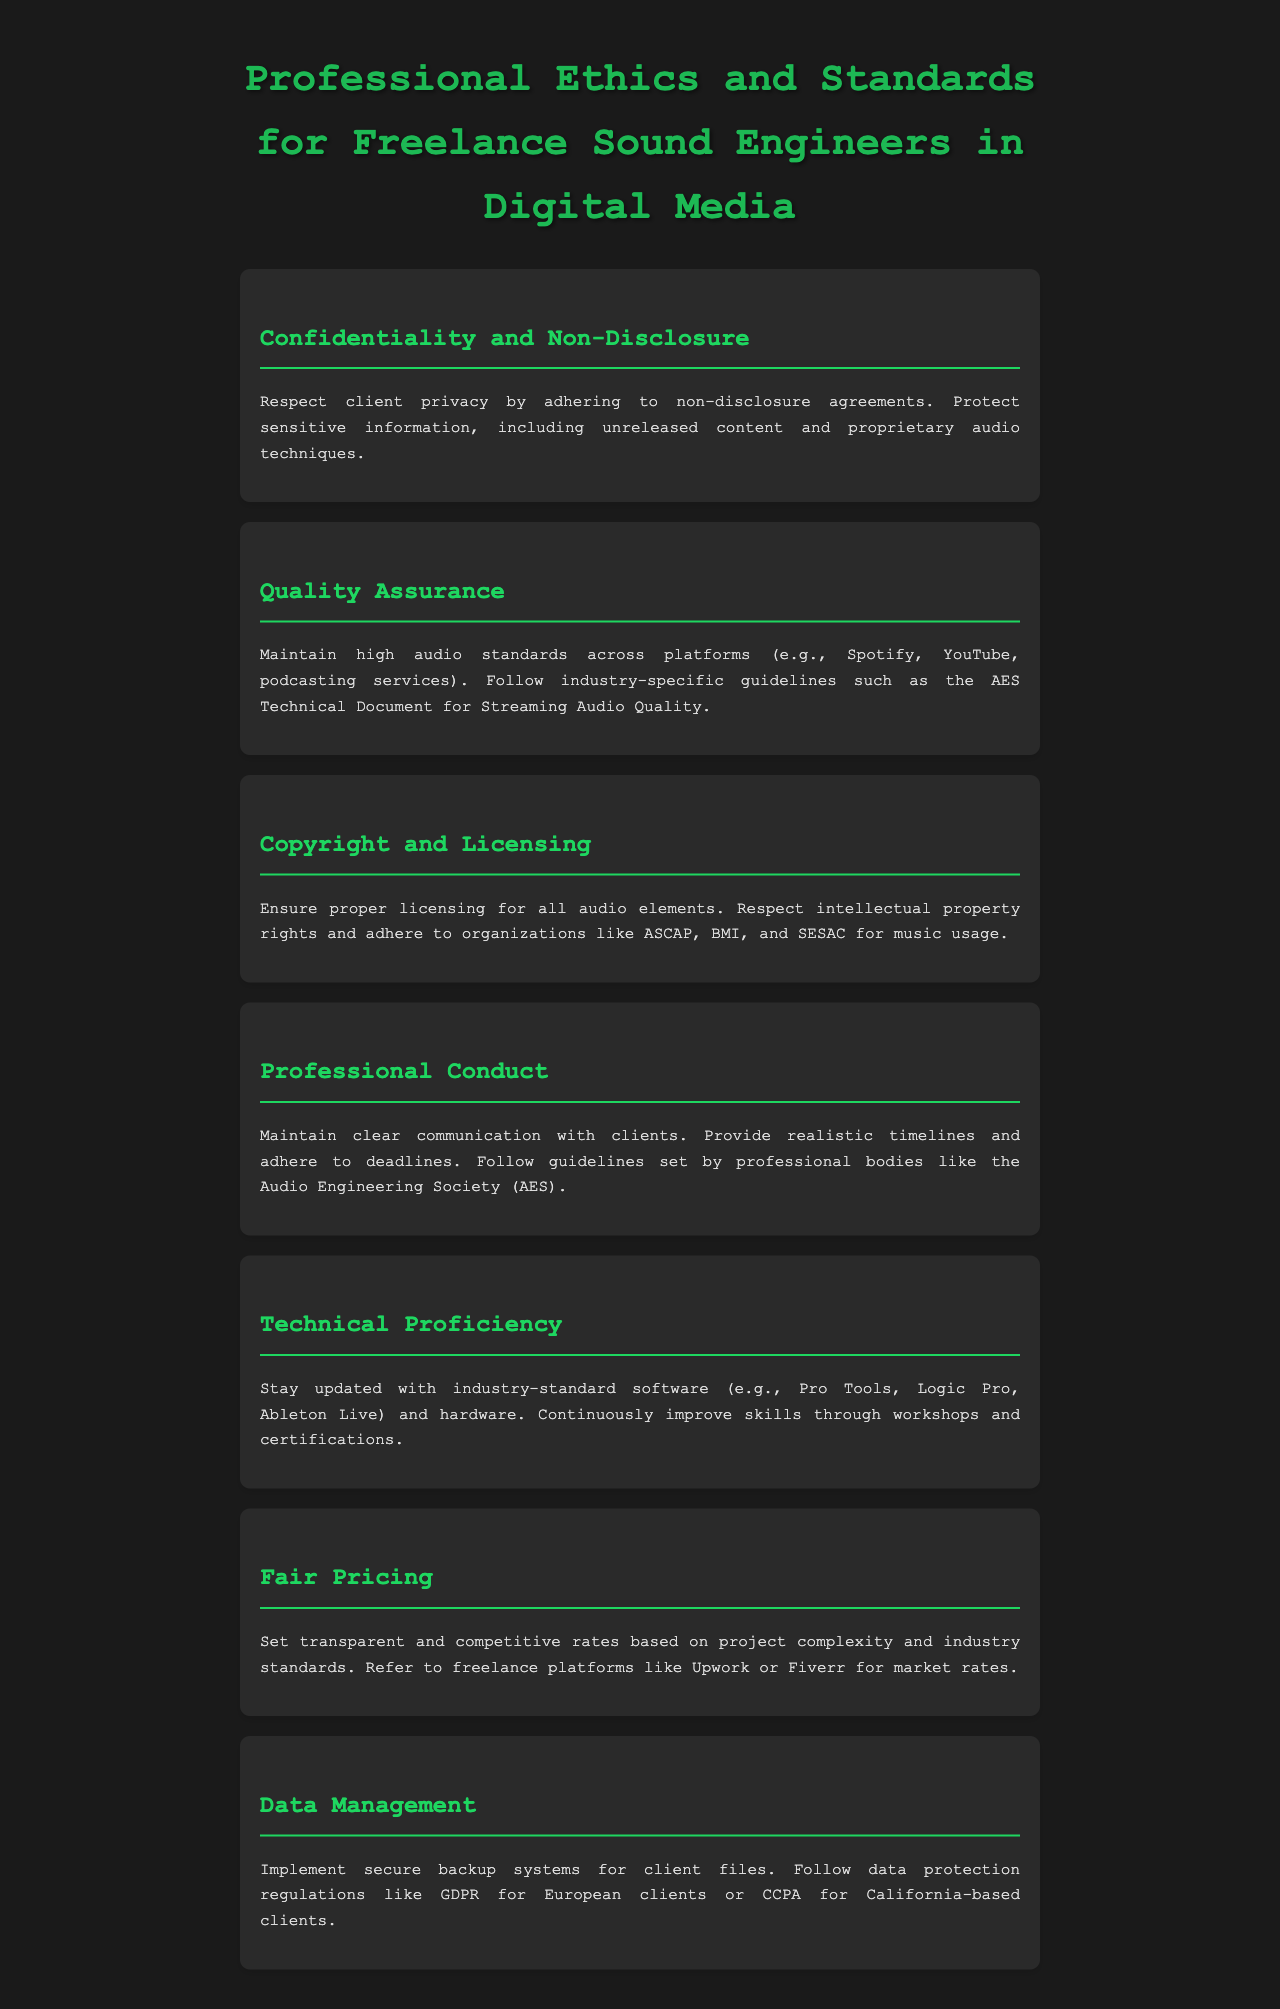what is the title of the document? The title of the document is prominently displayed at the top and indicates the subject matter.
Answer: Professional Ethics and Standards for Freelance Sound Engineers in Digital Media what principle do freelance sound engineers need to respect regarding client information? The principle mentioned in the section emphasizes the importance of privacy and protecting sensitive information.
Answer: Confidentiality and Non-Disclosure which organizations are referenced for music usage rights? The document lists organizations that provide guidance on music licensing for sound engineers.
Answer: ASCAP, BMI, and SESAC what should freelance sound engineers maintain across platforms? This information comes from a section focusing on standards that need to be upheld across different audio platforms.
Answer: High audio standards which software is suggested for staying updated on technical proficiency? The document mentions specific software that freelancers should be familiar with to remain competent.
Answer: Pro Tools, Logic Pro, Ableton Live what must sound engineers implement for client files? This requirement is highlighted in the section about data management.
Answer: Secure backup systems what is a suggested source for setting fair pricing? This includes resources to help freelancers determine their rates based on market conditions.
Answer: Freelance platforms like Upwork or Fiverr 